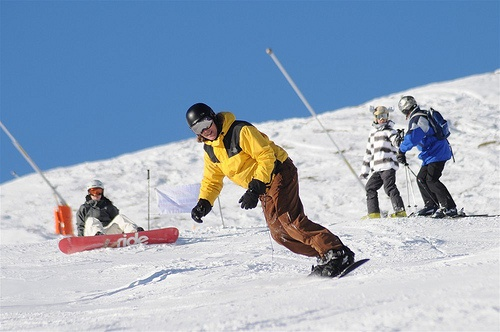Describe the objects in this image and their specific colors. I can see people in gray, black, gold, olive, and maroon tones, people in gray, black, navy, and darkblue tones, people in gray, lightgray, darkgray, and black tones, snowboard in gray, brown, salmon, and darkgray tones, and people in gray, black, lightgray, and darkgray tones in this image. 